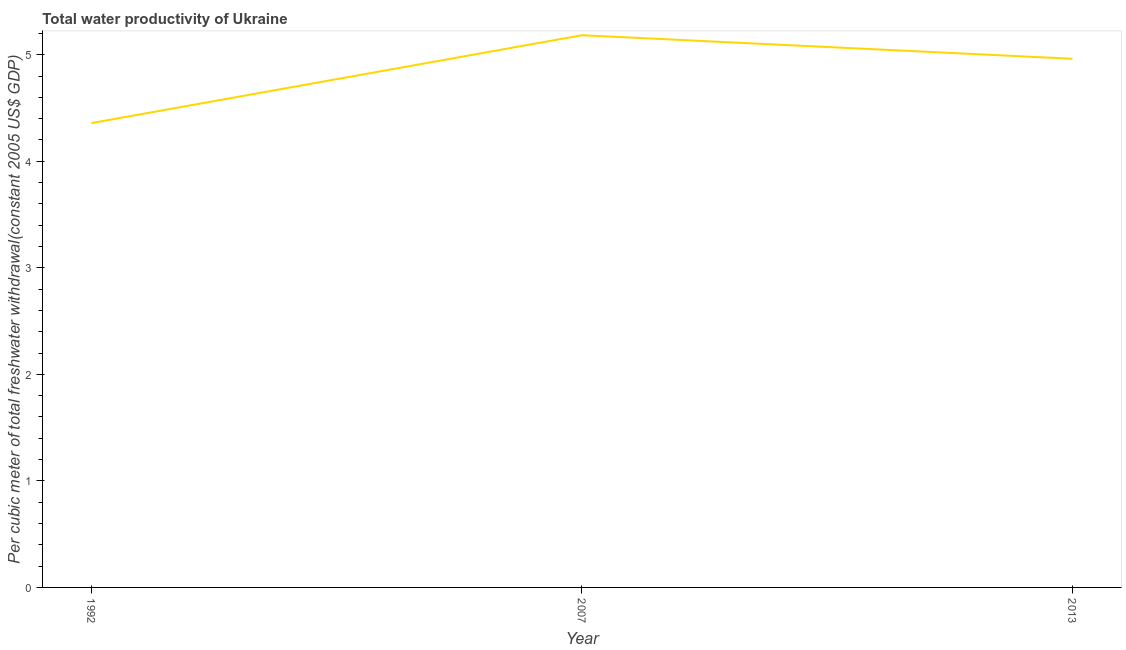What is the total water productivity in 2013?
Offer a very short reply. 4.96. Across all years, what is the maximum total water productivity?
Ensure brevity in your answer.  5.18. Across all years, what is the minimum total water productivity?
Offer a terse response. 4.36. In which year was the total water productivity maximum?
Keep it short and to the point. 2007. In which year was the total water productivity minimum?
Provide a short and direct response. 1992. What is the sum of the total water productivity?
Make the answer very short. 14.51. What is the difference between the total water productivity in 1992 and 2013?
Give a very brief answer. -0.6. What is the average total water productivity per year?
Give a very brief answer. 4.84. What is the median total water productivity?
Provide a short and direct response. 4.96. What is the ratio of the total water productivity in 1992 to that in 2013?
Offer a terse response. 0.88. Is the total water productivity in 2007 less than that in 2013?
Make the answer very short. No. Is the difference between the total water productivity in 2007 and 2013 greater than the difference between any two years?
Keep it short and to the point. No. What is the difference between the highest and the second highest total water productivity?
Ensure brevity in your answer.  0.22. Is the sum of the total water productivity in 1992 and 2013 greater than the maximum total water productivity across all years?
Make the answer very short. Yes. What is the difference between the highest and the lowest total water productivity?
Offer a terse response. 0.82. In how many years, is the total water productivity greater than the average total water productivity taken over all years?
Give a very brief answer. 2. How many lines are there?
Your response must be concise. 1. What is the difference between two consecutive major ticks on the Y-axis?
Your response must be concise. 1. Are the values on the major ticks of Y-axis written in scientific E-notation?
Offer a terse response. No. What is the title of the graph?
Your response must be concise. Total water productivity of Ukraine. What is the label or title of the X-axis?
Make the answer very short. Year. What is the label or title of the Y-axis?
Ensure brevity in your answer.  Per cubic meter of total freshwater withdrawal(constant 2005 US$ GDP). What is the Per cubic meter of total freshwater withdrawal(constant 2005 US$ GDP) of 1992?
Offer a terse response. 4.36. What is the Per cubic meter of total freshwater withdrawal(constant 2005 US$ GDP) in 2007?
Ensure brevity in your answer.  5.18. What is the Per cubic meter of total freshwater withdrawal(constant 2005 US$ GDP) in 2013?
Ensure brevity in your answer.  4.96. What is the difference between the Per cubic meter of total freshwater withdrawal(constant 2005 US$ GDP) in 1992 and 2007?
Make the answer very short. -0.82. What is the difference between the Per cubic meter of total freshwater withdrawal(constant 2005 US$ GDP) in 1992 and 2013?
Your response must be concise. -0.6. What is the difference between the Per cubic meter of total freshwater withdrawal(constant 2005 US$ GDP) in 2007 and 2013?
Your response must be concise. 0.22. What is the ratio of the Per cubic meter of total freshwater withdrawal(constant 2005 US$ GDP) in 1992 to that in 2007?
Give a very brief answer. 0.84. What is the ratio of the Per cubic meter of total freshwater withdrawal(constant 2005 US$ GDP) in 1992 to that in 2013?
Provide a succinct answer. 0.88. What is the ratio of the Per cubic meter of total freshwater withdrawal(constant 2005 US$ GDP) in 2007 to that in 2013?
Your answer should be compact. 1.04. 